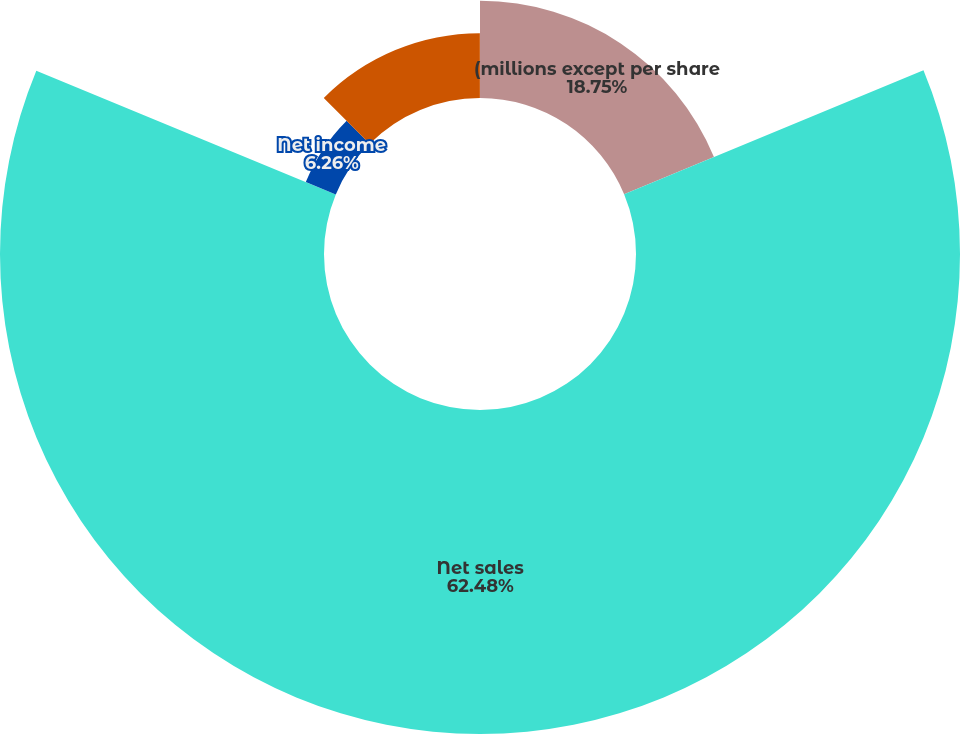Convert chart to OTSL. <chart><loc_0><loc_0><loc_500><loc_500><pie_chart><fcel>(millions except per share<fcel>Net sales<fcel>Net income<fcel>Net income attributable to<fcel>Net earnings per share<nl><fcel>18.75%<fcel>62.48%<fcel>6.26%<fcel>12.5%<fcel>0.01%<nl></chart> 